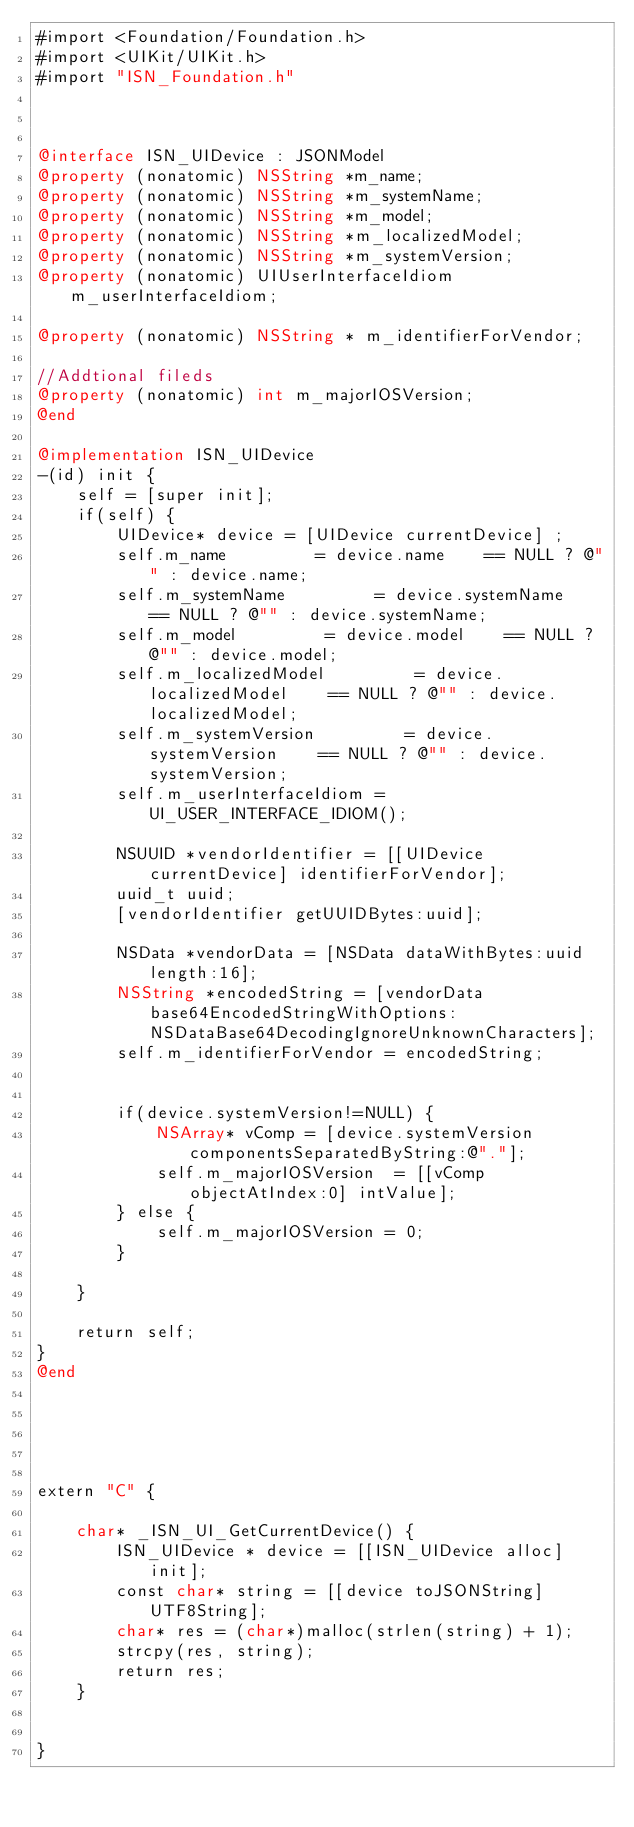Convert code to text. <code><loc_0><loc_0><loc_500><loc_500><_ObjectiveC_>#import <Foundation/Foundation.h>
#import <UIKit/UIKit.h>
#import "ISN_Foundation.h"



@interface ISN_UIDevice : JSONModel
@property (nonatomic) NSString *m_name;
@property (nonatomic) NSString *m_systemName;
@property (nonatomic) NSString *m_model;
@property (nonatomic) NSString *m_localizedModel;
@property (nonatomic) NSString *m_systemVersion;
@property (nonatomic) UIUserInterfaceIdiom m_userInterfaceIdiom;

@property (nonatomic) NSString * m_identifierForVendor;

//Addtional fileds
@property (nonatomic) int m_majorIOSVersion;
@end

@implementation ISN_UIDevice
-(id) init {
    self = [super init];
    if(self) {
        UIDevice* device = [UIDevice currentDevice] ;
        self.m_name         = device.name    == NULL ? @"" : device.name;
        self.m_systemName         = device.systemName    == NULL ? @"" : device.systemName;
        self.m_model         = device.model    == NULL ? @"" : device.model;
        self.m_localizedModel         = device.localizedModel    == NULL ? @"" : device.localizedModel;
        self.m_systemVersion         = device.systemVersion    == NULL ? @"" : device.systemVersion;
        self.m_userInterfaceIdiom = UI_USER_INTERFACE_IDIOM();
       
        NSUUID *vendorIdentifier = [[UIDevice currentDevice] identifierForVendor];
        uuid_t uuid;
        [vendorIdentifier getUUIDBytes:uuid];
        
        NSData *vendorData = [NSData dataWithBytes:uuid length:16];
        NSString *encodedString = [vendorData base64EncodedStringWithOptions:NSDataBase64DecodingIgnoreUnknownCharacters];
        self.m_identifierForVendor = encodedString;
        
        
        if(device.systemVersion!=NULL) {
            NSArray* vComp = [device.systemVersion componentsSeparatedByString:@"."];
            self.m_majorIOSVersion  = [[vComp objectAtIndex:0] intValue];
        } else {
            self.m_majorIOSVersion = 0;
        }
       
    }
    
    return self;
}
@end





extern "C" {
    
    char* _ISN_UI_GetCurrentDevice() {
        ISN_UIDevice * device = [[ISN_UIDevice alloc] init];
        const char* string = [[device toJSONString] UTF8String];
        char* res = (char*)malloc(strlen(string) + 1);
        strcpy(res, string);
        return res;
    }

  
}

    



</code> 